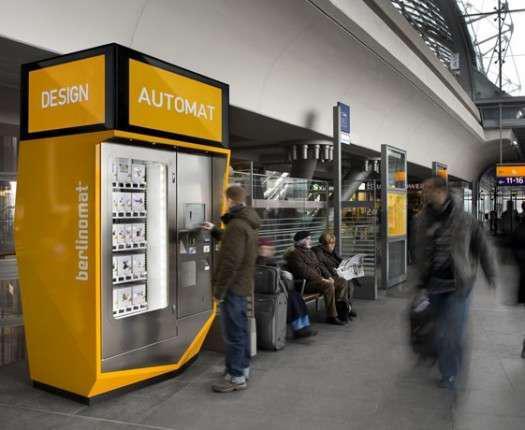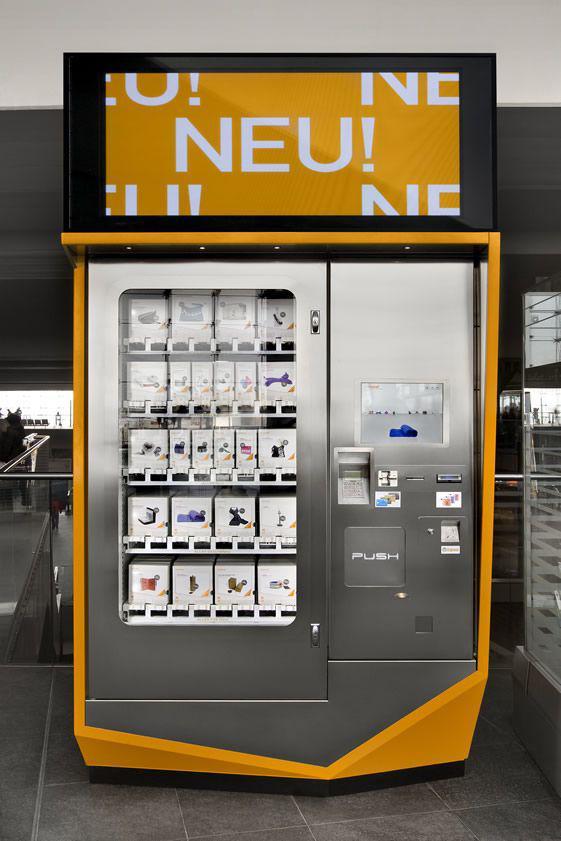The first image is the image on the left, the second image is the image on the right. For the images displayed, is the sentence "There is a kiosk with people nearby." factually correct? Answer yes or no. Yes. 